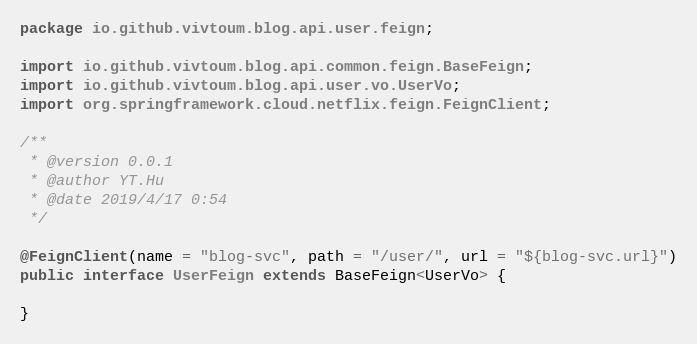Convert code to text. <code><loc_0><loc_0><loc_500><loc_500><_Java_>package io.github.vivtoum.blog.api.user.feign;

import io.github.vivtoum.blog.api.common.feign.BaseFeign;
import io.github.vivtoum.blog.api.user.vo.UserVo;
import org.springframework.cloud.netflix.feign.FeignClient;

/**
 * @version 0.0.1
 * @author YT.Hu
 * @date 2019/4/17 0:54
 */

@FeignClient(name = "blog-svc", path = "/user/", url = "${blog-svc.url}")
public interface UserFeign extends BaseFeign<UserVo> {

}
</code> 